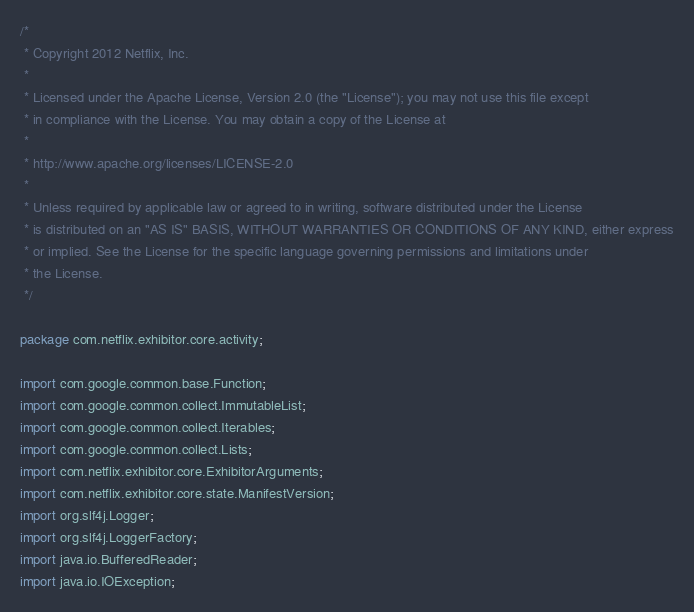<code> <loc_0><loc_0><loc_500><loc_500><_Java_>/*
 * Copyright 2012 Netflix, Inc.
 *
 * Licensed under the Apache License, Version 2.0 (the "License"); you may not use this file except
 * in compliance with the License. You may obtain a copy of the License at
 *
 * http://www.apache.org/licenses/LICENSE-2.0
 *
 * Unless required by applicable law or agreed to in writing, software distributed under the License
 * is distributed on an "AS IS" BASIS, WITHOUT WARRANTIES OR CONDITIONS OF ANY KIND, either express
 * or implied. See the License for the specific language governing permissions and limitations under
 * the License.
 */

package com.netflix.exhibitor.core.activity;

import com.google.common.base.Function;
import com.google.common.collect.ImmutableList;
import com.google.common.collect.Iterables;
import com.google.common.collect.Lists;
import com.netflix.exhibitor.core.ExhibitorArguments;
import com.netflix.exhibitor.core.state.ManifestVersion;
import org.slf4j.Logger;
import org.slf4j.LoggerFactory;
import java.io.BufferedReader;
import java.io.IOException;</code> 